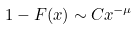<formula> <loc_0><loc_0><loc_500><loc_500>1 - F ( x ) \sim C x ^ { - \mu }</formula> 